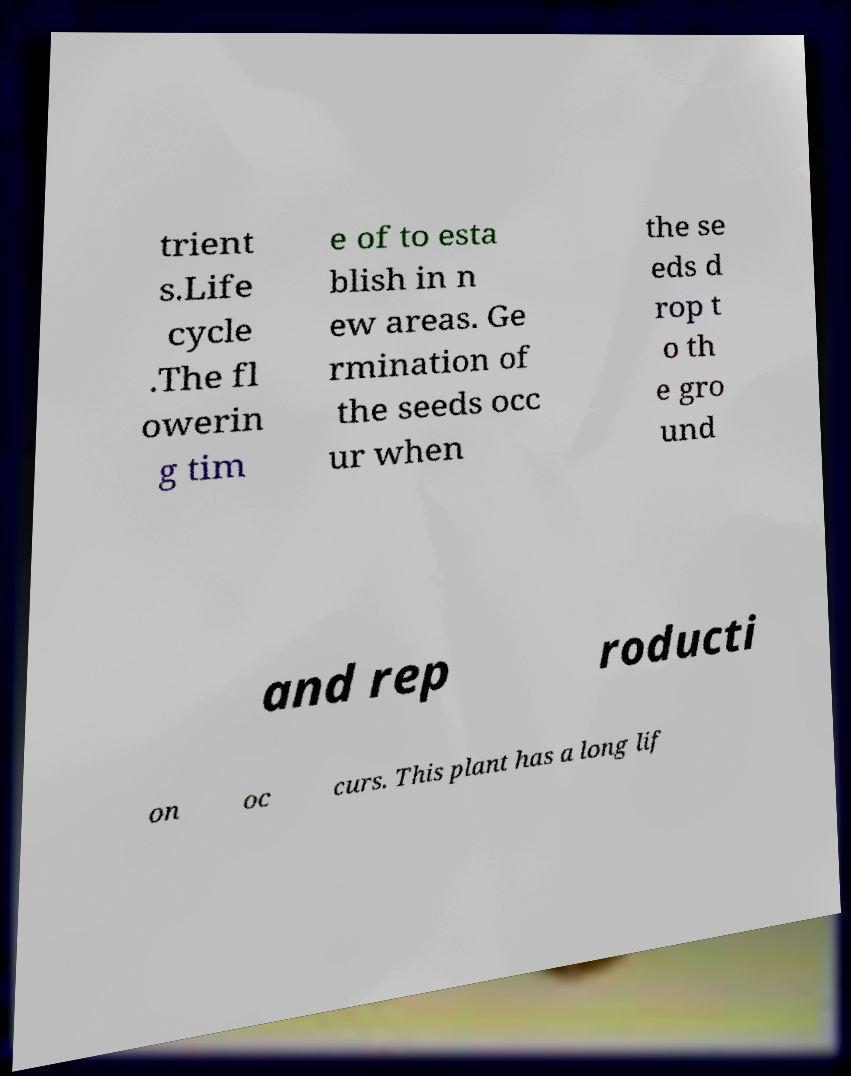What messages or text are displayed in this image? I need them in a readable, typed format. trient s.Life cycle .The fl owerin g tim e of to esta blish in n ew areas. Ge rmination of the seeds occ ur when the se eds d rop t o th e gro und and rep roducti on oc curs. This plant has a long lif 